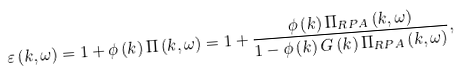<formula> <loc_0><loc_0><loc_500><loc_500>\varepsilon \left ( k , \omega \right ) = 1 + \phi \left ( k \right ) \Pi \left ( k , \omega \right ) = 1 + \frac { \phi \left ( k \right ) \Pi _ { R P A } \left ( k , \omega \right ) } { 1 - \phi \left ( k \right ) G \left ( k \right ) \Pi _ { R P A } \left ( k , \omega \right ) } ,</formula> 